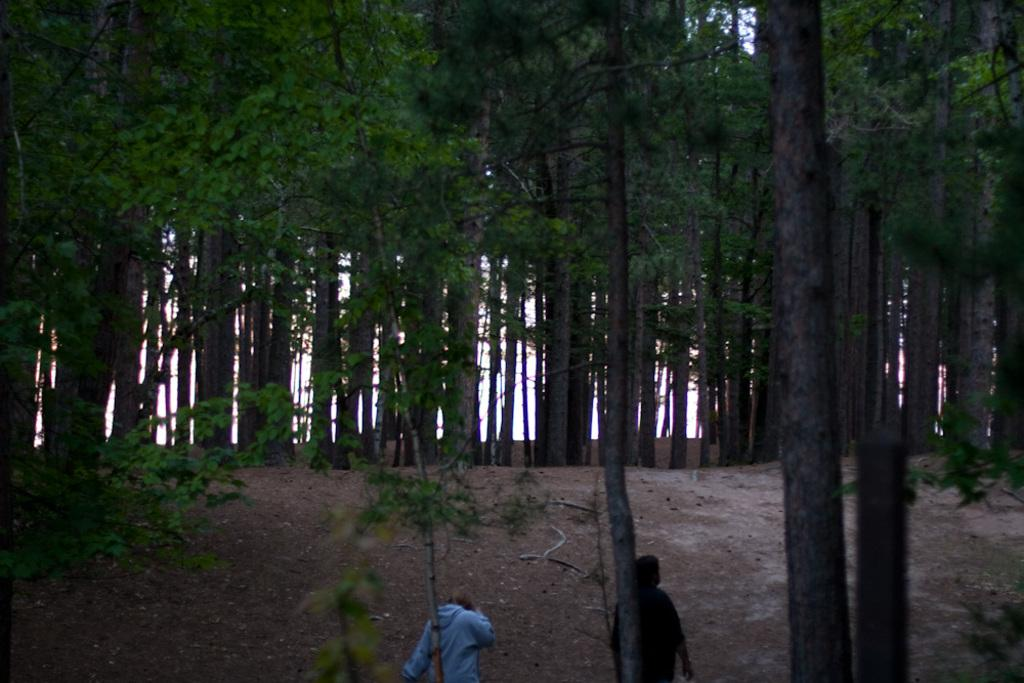What are the people in the image doing? The people in the image are walking on the land. What can be seen in the background of the image? Trees are present in the background of the image. What type of liquid can be seen flowing through the boat in the image? There is no boat present in the image, so it is not possible to determine if there is any liquid flowing through it. 